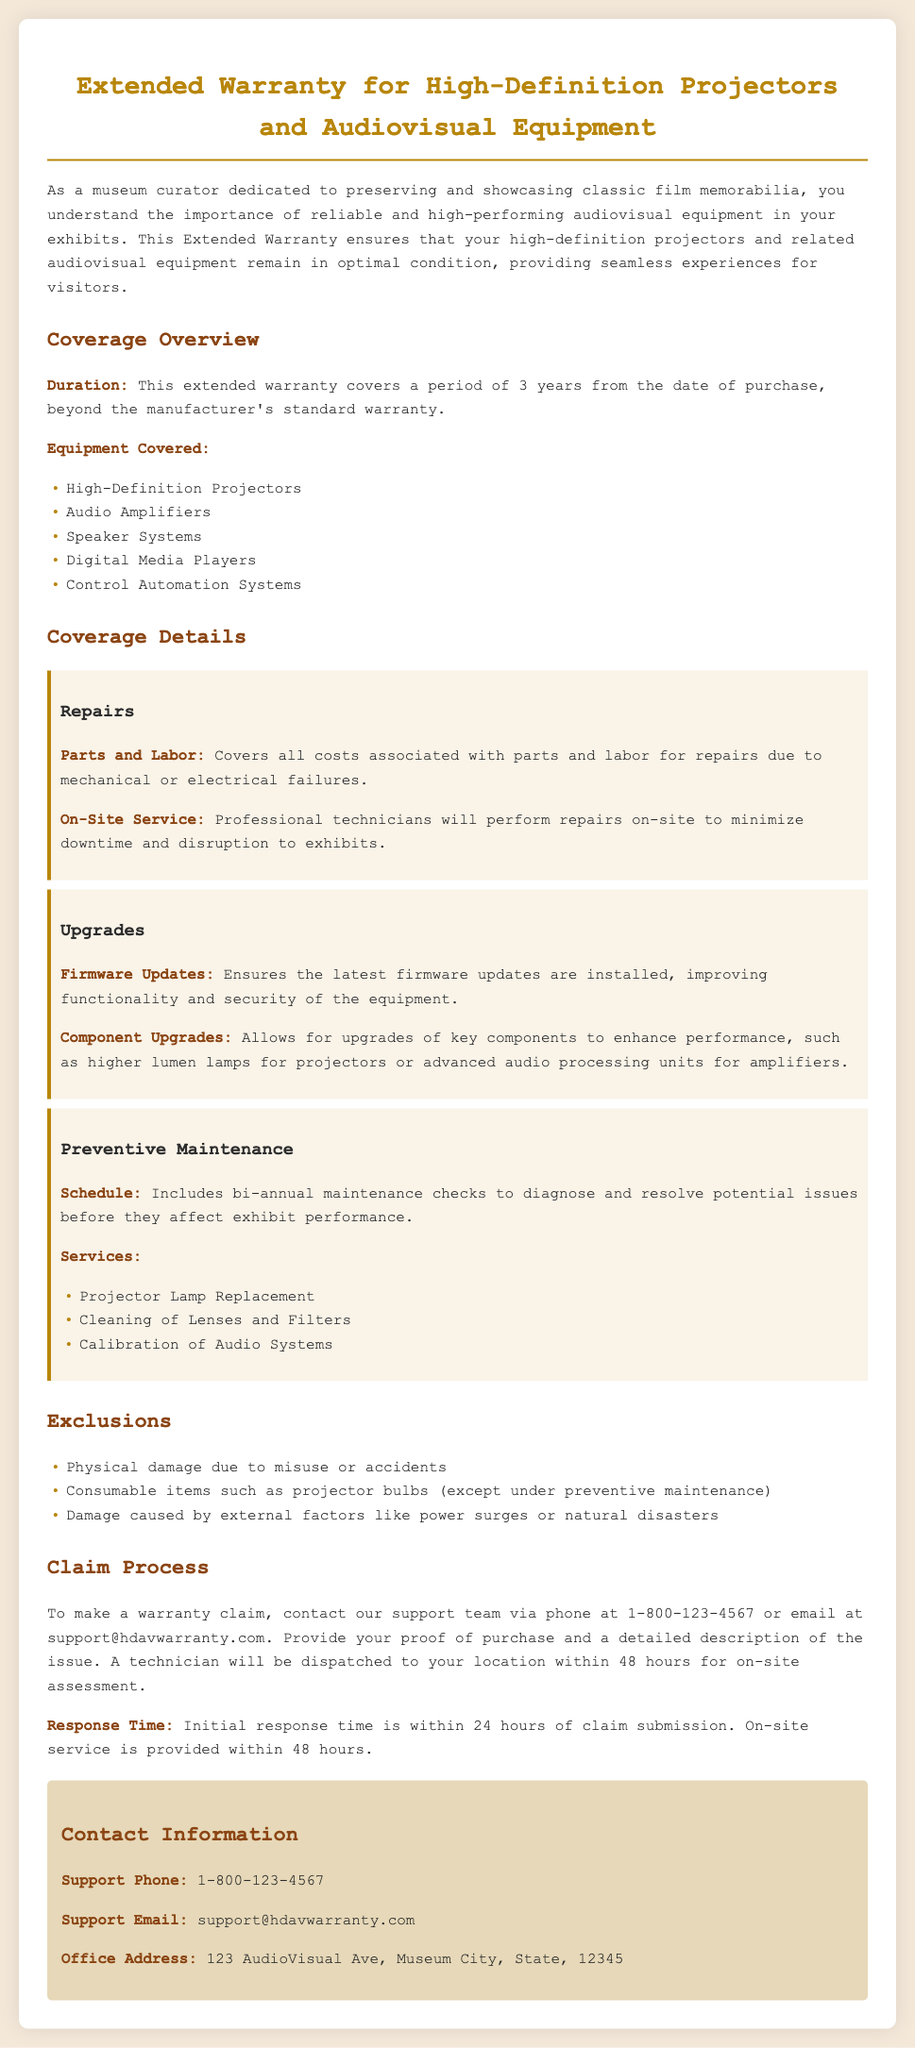What is the duration of the extended warranty? The document states that the extended warranty covers a period of 3 years from the date of purchase.
Answer: 3 years What equipment is covered under this warranty? The document lists the items covered under the warranty, including High-Definition Projectors and more.
Answer: High-Definition Projectors, Audio Amplifiers, Speaker Systems, Digital Media Players, Control Automation Systems What type of service will be provided for repairs? According to the document, professional technicians will perform repairs on-site to minimize downtime and disruption.
Answer: On-Site Service How often are preventive maintenance checks scheduled? The document mentions that preventive maintenance checks are conducted bi-annually.
Answer: Bi-annual What is excluded from the warranty coverage? The document provides a list of exclusions, including physical damage due to misuse.
Answer: Physical damage due to misuse or accidents What is the initial response time for a warranty claim? The document specifies that the initial response time is within 24 hours of claim submission.
Answer: 24 hours What types of upgrades are included in the warranty? The document outlines that firmware updates and component upgrades are included in the warranty.
Answer: Firmware Updates, Component Upgrades What is the contact phone number for support? The document includes a support phone number for warranty claims.
Answer: 1-800-123-4567 